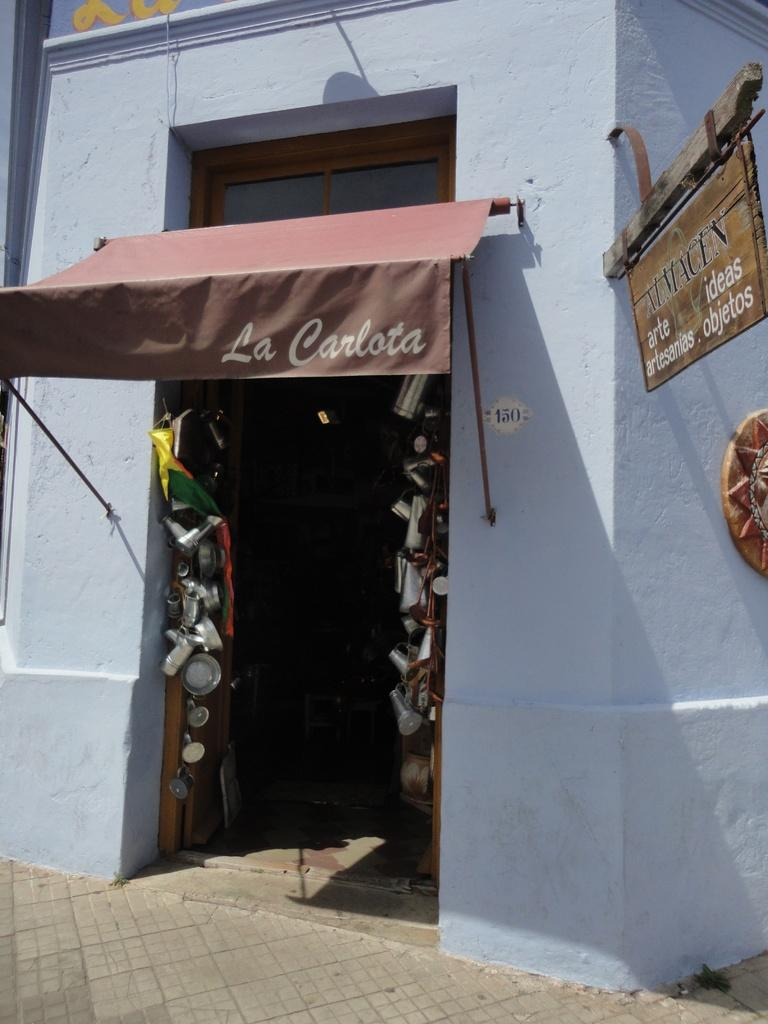What is the main object in the center of the image? There is a door in the center of the image. What is located near the door? There is a sign board in the image. What is the background of the image made of? There is a wall in the image. What can be seen at the bottom of the image? There is a road visible at the bottom of the image. What type of powder is being used for the voyage in the image? There is no voyage or powder present in the image; it features a door, a sign board, a wall, and a road. 